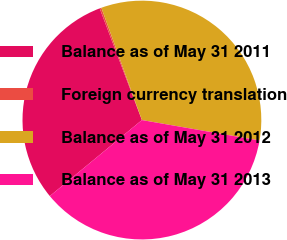Convert chart. <chart><loc_0><loc_0><loc_500><loc_500><pie_chart><fcel>Balance as of May 31 2011<fcel>Foreign currency translation<fcel>Balance as of May 31 2012<fcel>Balance as of May 31 2013<nl><fcel>30.23%<fcel>0.24%<fcel>33.25%<fcel>36.28%<nl></chart> 